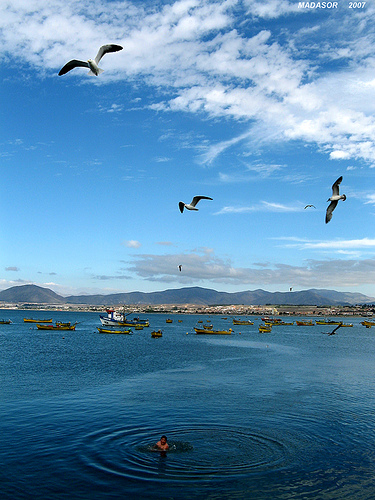How many boats are in the picture? In the tranquil blue waters of the bay, there are actually three boats visible, each in its own space, seemingly in a standby mode, possibly waiting for the day's activities. The clarity of the water and the calmness of the day give an impression of a leisurely pace of life by the sea. 